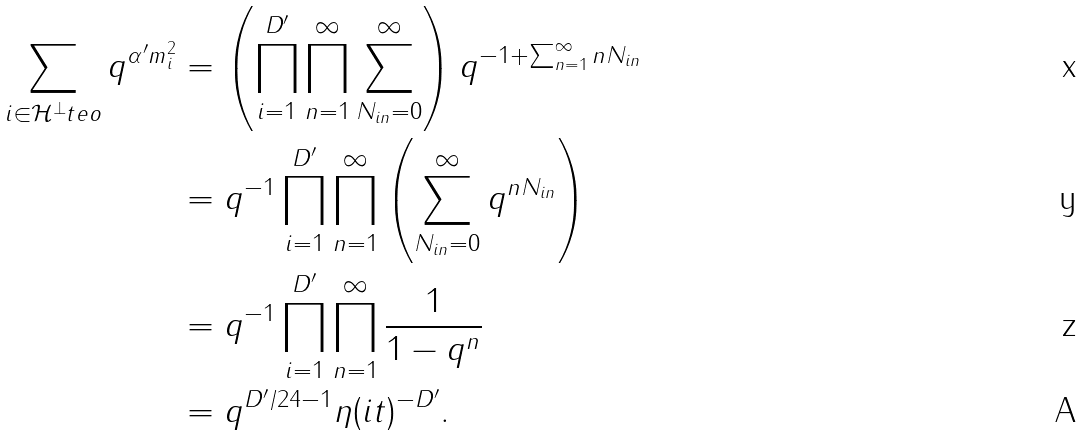Convert formula to latex. <formula><loc_0><loc_0><loc_500><loc_500>\sum _ { i \in \mathcal { H } ^ { \perp } _ { \ } t e { o } } q ^ { \alpha ^ { \prime } m ^ { 2 } _ { i } } & = \left ( \prod _ { i = 1 } ^ { D ^ { \prime } } \prod _ { n = 1 } ^ { \infty } \sum _ { N _ { i n } = 0 } ^ { \infty } \right ) q ^ { - 1 + \sum _ { n = 1 } ^ { \infty } n N _ { i n } } \\ & = q ^ { - 1 } \prod _ { i = 1 } ^ { D ^ { \prime } } \prod _ { n = 1 } ^ { \infty } \left ( \sum _ { N _ { i n } = 0 } ^ { \infty } q ^ { n N _ { i n } } \right ) \\ & = q ^ { - 1 } \prod _ { i = 1 } ^ { D ^ { \prime } } \prod _ { n = 1 } ^ { \infty } \frac { 1 } { 1 - q ^ { n } } \\ & = q ^ { D ^ { \prime } / 2 4 - 1 } \eta ( i t ) ^ { - D ^ { \prime } } .</formula> 